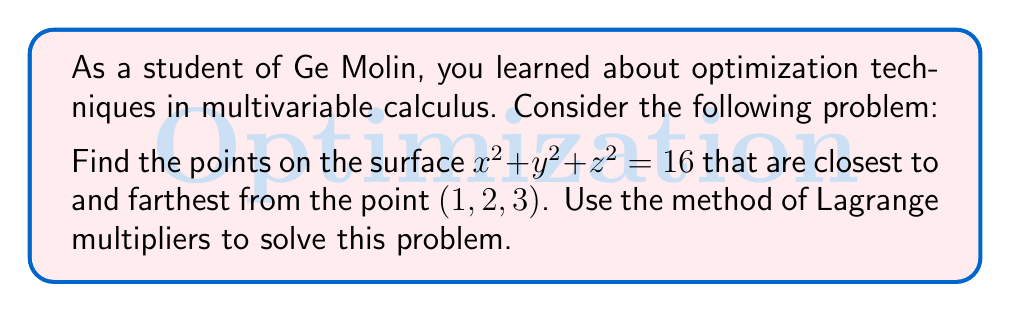Could you help me with this problem? Let's approach this step-by-step using Lagrange multipliers:

1) Define the function to be optimized:
   The distance from a point $(x, y, z)$ on the surface to $(1, 2, 3)$ is given by:
   $$f(x, y, z) = \sqrt{(x-1)^2 + (y-2)^2 + (z-3)^2}$$

2) Define the constraint:
   $$g(x, y, z) = x^2 + y^2 + z^2 - 16 = 0$$

3) Form the Lagrangian:
   $$L(x, y, z, \lambda) = f(x, y, z) - \lambda g(x, y, z)$$

4) Set up the system of equations:
   $$\frac{\partial L}{\partial x} = \frac{x-1}{\sqrt{(x-1)^2 + (y-2)^2 + (z-3)^2}} - 2\lambda x = 0$$
   $$\frac{\partial L}{\partial y} = \frac{y-2}{\sqrt{(x-1)^2 + (y-2)^2 + (z-3)^2}} - 2\lambda y = 0$$
   $$\frac{\partial L}{\partial z} = \frac{z-3}{\sqrt{(x-1)^2 + (y-2)^2 + (z-3)^2}} - 2\lambda z = 0$$
   $$\frac{\partial L}{\partial \lambda} = x^2 + y^2 + z^2 - 16 = 0$$

5) From the first three equations, we can deduce:
   $$\frac{x-1}{x} = \frac{y-2}{y} = \frac{z-3}{z} = 2\lambda\sqrt{(x-1)^2 + (y-2)^2 + (z-3)^2}$$

6) This implies that $(x, y, z)$ is collinear with $(1, 2, 3)$. So, we can write:
   $$(x, y, z) = k(1, 2, 3)$$
   where $k$ is some scalar.

7) Substituting into the constraint equation:
   $$k^2(1^2 + 2^2 + 3^2) = 16$$
   $$14k^2 = 16$$
   $$k^2 = \frac{8}{7}$$

8) This gives us two solutions:
   $$k = \pm\sqrt{\frac{8}{7}}$$

9) Therefore, the two points are:
   $$(\sqrt{\frac{8}{7}}, 2\sqrt{\frac{8}{7}}, 3\sqrt{\frac{8}{7}}) \approx (1.069, 2.138, 3.207)$$
   $$(-\sqrt{\frac{8}{7}}, -2\sqrt{\frac{8}{7}}, -3\sqrt{\frac{8}{7}}) \approx (-1.069, -2.138, -3.207)$$

10) The point with positive coordinates is closest to $(1, 2, 3)$, while the point with negative coordinates is farthest.
Answer: Closest point: $(\sqrt{\frac{8}{7}}, 2\sqrt{\frac{8}{7}}, 3\sqrt{\frac{8}{7}})$
Farthest point: $(-\sqrt{\frac{8}{7}}, -2\sqrt{\frac{8}{7}}, -3\sqrt{\frac{8}{7}})$ 